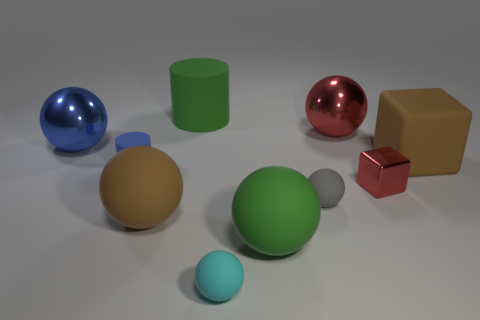Subtract all large rubber balls. How many balls are left? 4 Subtract all brown balls. How many balls are left? 5 Subtract 3 spheres. How many spheres are left? 3 Subtract all yellow balls. Subtract all blue cubes. How many balls are left? 6 Subtract all cylinders. How many objects are left? 8 Subtract all small cyan objects. Subtract all brown matte spheres. How many objects are left? 8 Add 1 rubber things. How many rubber things are left? 8 Add 5 big brown objects. How many big brown objects exist? 7 Subtract 1 red cubes. How many objects are left? 9 